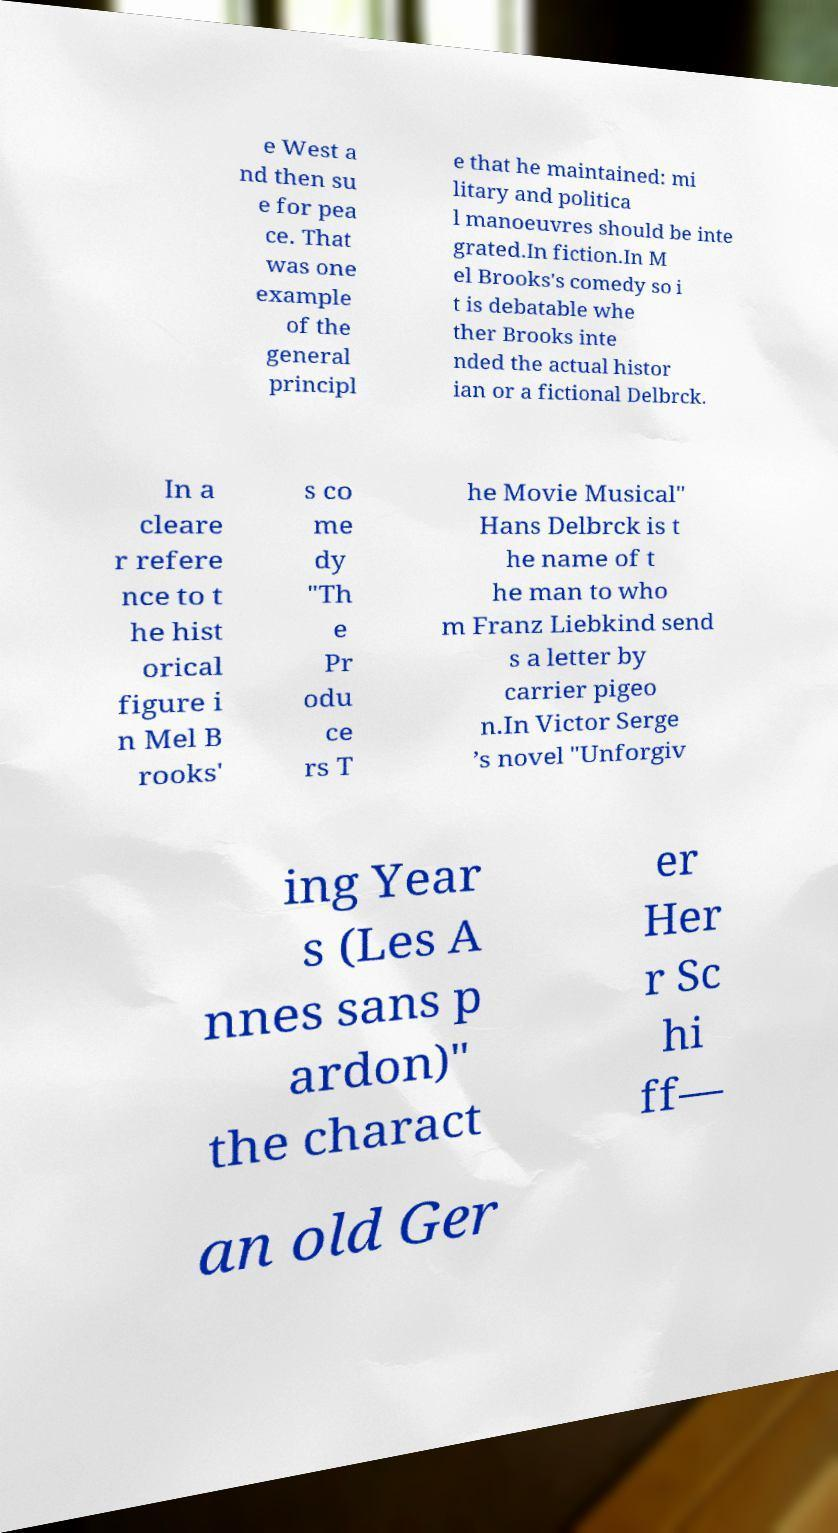Please identify and transcribe the text found in this image. e West a nd then su e for pea ce. That was one example of the general principl e that he maintained: mi litary and politica l manoeuvres should be inte grated.In fiction.In M el Brooks's comedy so i t is debatable whe ther Brooks inte nded the actual histor ian or a fictional Delbrck. In a cleare r refere nce to t he hist orical figure i n Mel B rooks' s co me dy "Th e Pr odu ce rs T he Movie Musical" Hans Delbrck is t he name of t he man to who m Franz Liebkind send s a letter by carrier pigeo n.In Victor Serge ’s novel "Unforgiv ing Year s (Les A nnes sans p ardon)" the charact er Her r Sc hi ff— an old Ger 